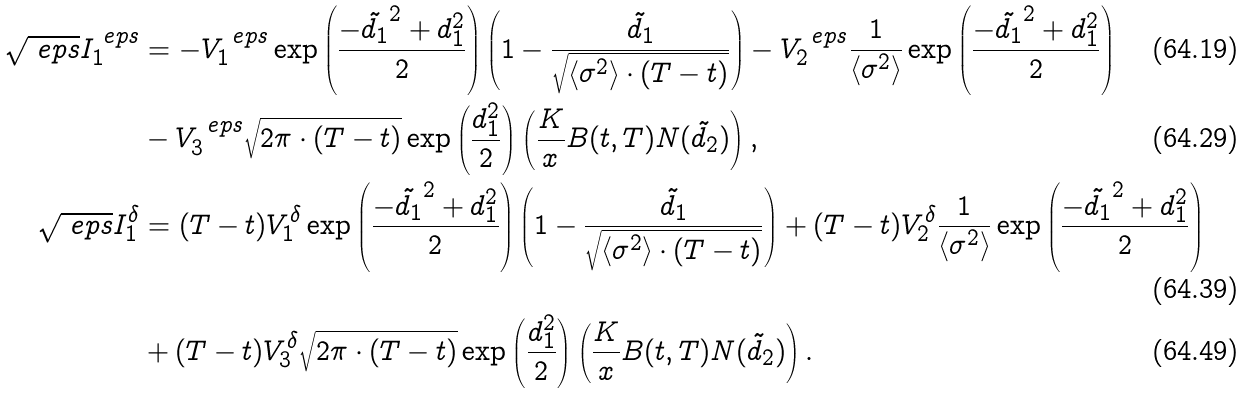Convert formula to latex. <formula><loc_0><loc_0><loc_500><loc_500>\sqrt { \ e p s } I _ { 1 } ^ { \ e p s } & = - V _ { 1 } ^ { \ e p s } \exp \left ( \frac { - \tilde { d _ { 1 } } ^ { 2 } + d _ { 1 } ^ { 2 } } { 2 } \right ) \left ( 1 - \frac { \tilde { d _ { 1 } } } { \sqrt { \left < \sigma ^ { 2 } \right > \cdot ( T - t ) } } \right ) - V _ { 2 } ^ { \ e p s } \frac { 1 } { \left < \sigma ^ { 2 } \right > } \exp \left ( \frac { - \tilde { d _ { 1 } } ^ { 2 } + d _ { 1 } ^ { 2 } } { 2 } \right ) \\ & - V _ { 3 } ^ { \ e p s } \sqrt { 2 \pi \cdot ( T - t ) } \exp \left ( \frac { d _ { 1 } ^ { 2 } } { 2 } \right ) \left ( \frac { K } { x } B ( t , T ) N ( \tilde { d } _ { 2 } ) \right ) , \\ \sqrt { \ e p s } I _ { 1 } ^ { \delta } & = ( T - t ) V _ { 1 } ^ { \delta } \exp \left ( \frac { - \tilde { d _ { 1 } } ^ { 2 } + d _ { 1 } ^ { 2 } } { 2 } \right ) \left ( 1 - \frac { \tilde { d _ { 1 } } } { \sqrt { \left < \sigma ^ { 2 } \right > \cdot ( T - t ) } } \right ) + ( T - t ) V _ { 2 } ^ { \delta } \frac { 1 } { \left < \sigma ^ { 2 } \right > } \exp \left ( \frac { - \tilde { d _ { 1 } } ^ { 2 } + d _ { 1 } ^ { 2 } } { 2 } \right ) \\ & + ( T - t ) V _ { 3 } ^ { \delta } \sqrt { 2 \pi \cdot ( T - t ) } \exp \left ( \frac { d _ { 1 } ^ { 2 } } { 2 } \right ) \left ( \frac { K } { x } B ( t , T ) N ( \tilde { d } _ { 2 } ) \right ) .</formula> 